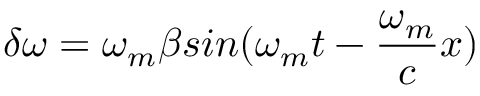<formula> <loc_0><loc_0><loc_500><loc_500>\delta \omega = \omega _ { m } \beta \sin ( \omega _ { m } t - \frac { \omega _ { m } } { c } x )</formula> 